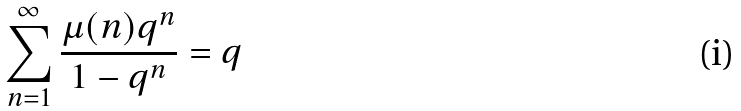Convert formula to latex. <formula><loc_0><loc_0><loc_500><loc_500>\sum _ { n = 1 } ^ { \infty } \frac { \mu ( n ) q ^ { n } } { 1 - q ^ { n } } = q</formula> 